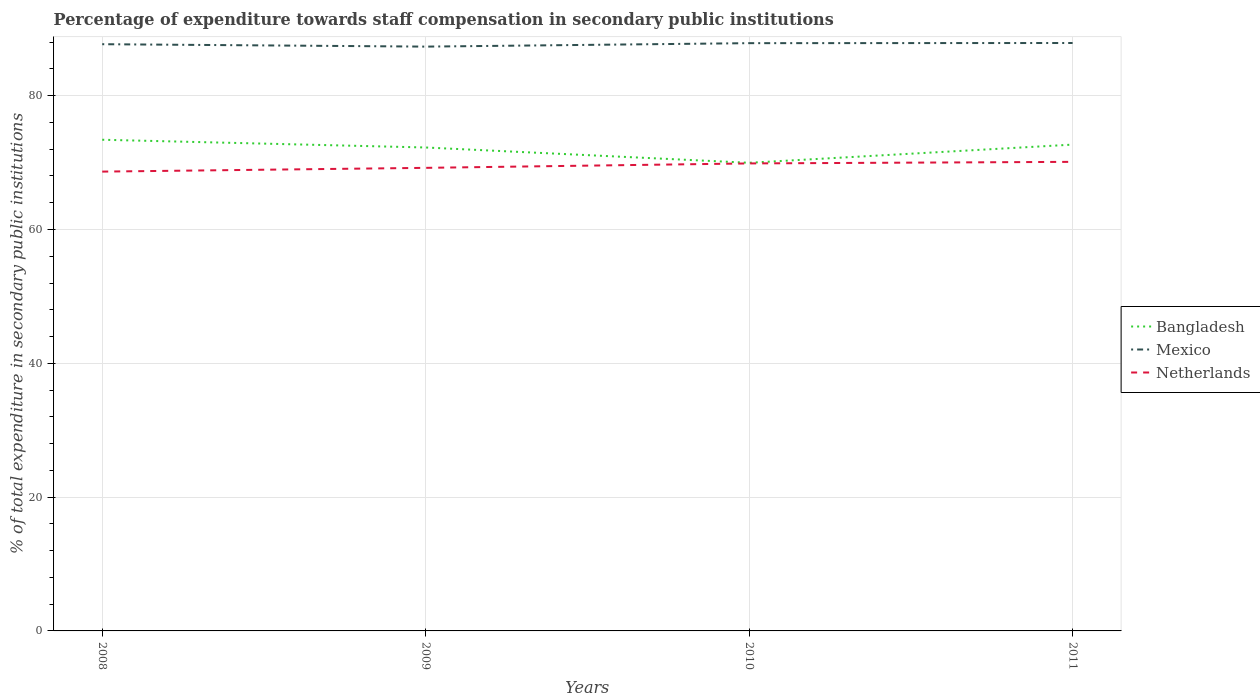How many different coloured lines are there?
Provide a succinct answer. 3. Is the number of lines equal to the number of legend labels?
Give a very brief answer. Yes. Across all years, what is the maximum percentage of expenditure towards staff compensation in Mexico?
Give a very brief answer. 87.34. In which year was the percentage of expenditure towards staff compensation in Bangladesh maximum?
Provide a succinct answer. 2010. What is the total percentage of expenditure towards staff compensation in Mexico in the graph?
Offer a very short reply. -0.54. What is the difference between the highest and the second highest percentage of expenditure towards staff compensation in Netherlands?
Provide a short and direct response. 1.46. How many years are there in the graph?
Your answer should be very brief. 4. What is the difference between two consecutive major ticks on the Y-axis?
Provide a succinct answer. 20. Are the values on the major ticks of Y-axis written in scientific E-notation?
Keep it short and to the point. No. Does the graph contain any zero values?
Keep it short and to the point. No. What is the title of the graph?
Make the answer very short. Percentage of expenditure towards staff compensation in secondary public institutions. Does "Panama" appear as one of the legend labels in the graph?
Keep it short and to the point. No. What is the label or title of the Y-axis?
Give a very brief answer. % of total expenditure in secondary public institutions. What is the % of total expenditure in secondary public institutions of Bangladesh in 2008?
Keep it short and to the point. 73.42. What is the % of total expenditure in secondary public institutions of Mexico in 2008?
Your answer should be very brief. 87.7. What is the % of total expenditure in secondary public institutions of Netherlands in 2008?
Offer a very short reply. 68.66. What is the % of total expenditure in secondary public institutions of Bangladesh in 2009?
Offer a very short reply. 72.26. What is the % of total expenditure in secondary public institutions of Mexico in 2009?
Keep it short and to the point. 87.34. What is the % of total expenditure in secondary public institutions of Netherlands in 2009?
Your response must be concise. 69.22. What is the % of total expenditure in secondary public institutions in Bangladesh in 2010?
Keep it short and to the point. 69.97. What is the % of total expenditure in secondary public institutions of Mexico in 2010?
Provide a short and direct response. 87.85. What is the % of total expenditure in secondary public institutions of Netherlands in 2010?
Keep it short and to the point. 69.88. What is the % of total expenditure in secondary public institutions of Bangladesh in 2011?
Offer a terse response. 72.69. What is the % of total expenditure in secondary public institutions in Mexico in 2011?
Your response must be concise. 87.88. What is the % of total expenditure in secondary public institutions in Netherlands in 2011?
Your answer should be very brief. 70.11. Across all years, what is the maximum % of total expenditure in secondary public institutions of Bangladesh?
Offer a very short reply. 73.42. Across all years, what is the maximum % of total expenditure in secondary public institutions of Mexico?
Your answer should be compact. 87.88. Across all years, what is the maximum % of total expenditure in secondary public institutions in Netherlands?
Make the answer very short. 70.11. Across all years, what is the minimum % of total expenditure in secondary public institutions in Bangladesh?
Offer a very short reply. 69.97. Across all years, what is the minimum % of total expenditure in secondary public institutions of Mexico?
Make the answer very short. 87.34. Across all years, what is the minimum % of total expenditure in secondary public institutions in Netherlands?
Keep it short and to the point. 68.66. What is the total % of total expenditure in secondary public institutions in Bangladesh in the graph?
Your answer should be very brief. 288.34. What is the total % of total expenditure in secondary public institutions in Mexico in the graph?
Provide a succinct answer. 350.77. What is the total % of total expenditure in secondary public institutions of Netherlands in the graph?
Give a very brief answer. 277.86. What is the difference between the % of total expenditure in secondary public institutions in Bangladesh in 2008 and that in 2009?
Provide a short and direct response. 1.16. What is the difference between the % of total expenditure in secondary public institutions in Mexico in 2008 and that in 2009?
Ensure brevity in your answer.  0.36. What is the difference between the % of total expenditure in secondary public institutions of Netherlands in 2008 and that in 2009?
Provide a succinct answer. -0.56. What is the difference between the % of total expenditure in secondary public institutions of Bangladesh in 2008 and that in 2010?
Make the answer very short. 3.44. What is the difference between the % of total expenditure in secondary public institutions of Mexico in 2008 and that in 2010?
Make the answer very short. -0.15. What is the difference between the % of total expenditure in secondary public institutions of Netherlands in 2008 and that in 2010?
Your answer should be very brief. -1.22. What is the difference between the % of total expenditure in secondary public institutions in Bangladesh in 2008 and that in 2011?
Make the answer very short. 0.73. What is the difference between the % of total expenditure in secondary public institutions in Mexico in 2008 and that in 2011?
Your response must be concise. -0.18. What is the difference between the % of total expenditure in secondary public institutions in Netherlands in 2008 and that in 2011?
Your answer should be very brief. -1.46. What is the difference between the % of total expenditure in secondary public institutions of Bangladesh in 2009 and that in 2010?
Your answer should be compact. 2.29. What is the difference between the % of total expenditure in secondary public institutions in Mexico in 2009 and that in 2010?
Provide a short and direct response. -0.52. What is the difference between the % of total expenditure in secondary public institutions in Netherlands in 2009 and that in 2010?
Provide a succinct answer. -0.66. What is the difference between the % of total expenditure in secondary public institutions in Bangladesh in 2009 and that in 2011?
Your response must be concise. -0.43. What is the difference between the % of total expenditure in secondary public institutions of Mexico in 2009 and that in 2011?
Your answer should be compact. -0.54. What is the difference between the % of total expenditure in secondary public institutions in Netherlands in 2009 and that in 2011?
Give a very brief answer. -0.9. What is the difference between the % of total expenditure in secondary public institutions of Bangladesh in 2010 and that in 2011?
Keep it short and to the point. -2.72. What is the difference between the % of total expenditure in secondary public institutions of Mexico in 2010 and that in 2011?
Provide a succinct answer. -0.02. What is the difference between the % of total expenditure in secondary public institutions in Netherlands in 2010 and that in 2011?
Provide a succinct answer. -0.24. What is the difference between the % of total expenditure in secondary public institutions of Bangladesh in 2008 and the % of total expenditure in secondary public institutions of Mexico in 2009?
Provide a short and direct response. -13.92. What is the difference between the % of total expenditure in secondary public institutions of Bangladesh in 2008 and the % of total expenditure in secondary public institutions of Netherlands in 2009?
Your answer should be very brief. 4.2. What is the difference between the % of total expenditure in secondary public institutions of Mexico in 2008 and the % of total expenditure in secondary public institutions of Netherlands in 2009?
Provide a succinct answer. 18.48. What is the difference between the % of total expenditure in secondary public institutions in Bangladesh in 2008 and the % of total expenditure in secondary public institutions in Mexico in 2010?
Your response must be concise. -14.44. What is the difference between the % of total expenditure in secondary public institutions of Bangladesh in 2008 and the % of total expenditure in secondary public institutions of Netherlands in 2010?
Your answer should be very brief. 3.54. What is the difference between the % of total expenditure in secondary public institutions of Mexico in 2008 and the % of total expenditure in secondary public institutions of Netherlands in 2010?
Make the answer very short. 17.82. What is the difference between the % of total expenditure in secondary public institutions in Bangladesh in 2008 and the % of total expenditure in secondary public institutions in Mexico in 2011?
Provide a succinct answer. -14.46. What is the difference between the % of total expenditure in secondary public institutions of Bangladesh in 2008 and the % of total expenditure in secondary public institutions of Netherlands in 2011?
Offer a terse response. 3.3. What is the difference between the % of total expenditure in secondary public institutions of Mexico in 2008 and the % of total expenditure in secondary public institutions of Netherlands in 2011?
Provide a short and direct response. 17.59. What is the difference between the % of total expenditure in secondary public institutions of Bangladesh in 2009 and the % of total expenditure in secondary public institutions of Mexico in 2010?
Keep it short and to the point. -15.59. What is the difference between the % of total expenditure in secondary public institutions in Bangladesh in 2009 and the % of total expenditure in secondary public institutions in Netherlands in 2010?
Offer a terse response. 2.38. What is the difference between the % of total expenditure in secondary public institutions in Mexico in 2009 and the % of total expenditure in secondary public institutions in Netherlands in 2010?
Keep it short and to the point. 17.46. What is the difference between the % of total expenditure in secondary public institutions in Bangladesh in 2009 and the % of total expenditure in secondary public institutions in Mexico in 2011?
Offer a very short reply. -15.62. What is the difference between the % of total expenditure in secondary public institutions in Bangladesh in 2009 and the % of total expenditure in secondary public institutions in Netherlands in 2011?
Your answer should be very brief. 2.15. What is the difference between the % of total expenditure in secondary public institutions in Mexico in 2009 and the % of total expenditure in secondary public institutions in Netherlands in 2011?
Keep it short and to the point. 17.22. What is the difference between the % of total expenditure in secondary public institutions in Bangladesh in 2010 and the % of total expenditure in secondary public institutions in Mexico in 2011?
Your answer should be very brief. -17.9. What is the difference between the % of total expenditure in secondary public institutions in Bangladesh in 2010 and the % of total expenditure in secondary public institutions in Netherlands in 2011?
Keep it short and to the point. -0.14. What is the difference between the % of total expenditure in secondary public institutions in Mexico in 2010 and the % of total expenditure in secondary public institutions in Netherlands in 2011?
Keep it short and to the point. 17.74. What is the average % of total expenditure in secondary public institutions in Bangladesh per year?
Your answer should be very brief. 72.09. What is the average % of total expenditure in secondary public institutions in Mexico per year?
Give a very brief answer. 87.69. What is the average % of total expenditure in secondary public institutions in Netherlands per year?
Your answer should be compact. 69.47. In the year 2008, what is the difference between the % of total expenditure in secondary public institutions in Bangladesh and % of total expenditure in secondary public institutions in Mexico?
Provide a short and direct response. -14.28. In the year 2008, what is the difference between the % of total expenditure in secondary public institutions of Bangladesh and % of total expenditure in secondary public institutions of Netherlands?
Provide a succinct answer. 4.76. In the year 2008, what is the difference between the % of total expenditure in secondary public institutions in Mexico and % of total expenditure in secondary public institutions in Netherlands?
Give a very brief answer. 19.04. In the year 2009, what is the difference between the % of total expenditure in secondary public institutions of Bangladesh and % of total expenditure in secondary public institutions of Mexico?
Offer a very short reply. -15.08. In the year 2009, what is the difference between the % of total expenditure in secondary public institutions of Bangladesh and % of total expenditure in secondary public institutions of Netherlands?
Offer a terse response. 3.04. In the year 2009, what is the difference between the % of total expenditure in secondary public institutions of Mexico and % of total expenditure in secondary public institutions of Netherlands?
Your answer should be compact. 18.12. In the year 2010, what is the difference between the % of total expenditure in secondary public institutions of Bangladesh and % of total expenditure in secondary public institutions of Mexico?
Provide a succinct answer. -17.88. In the year 2010, what is the difference between the % of total expenditure in secondary public institutions of Bangladesh and % of total expenditure in secondary public institutions of Netherlands?
Offer a terse response. 0.1. In the year 2010, what is the difference between the % of total expenditure in secondary public institutions in Mexico and % of total expenditure in secondary public institutions in Netherlands?
Ensure brevity in your answer.  17.98. In the year 2011, what is the difference between the % of total expenditure in secondary public institutions of Bangladesh and % of total expenditure in secondary public institutions of Mexico?
Provide a short and direct response. -15.19. In the year 2011, what is the difference between the % of total expenditure in secondary public institutions of Bangladesh and % of total expenditure in secondary public institutions of Netherlands?
Give a very brief answer. 2.58. In the year 2011, what is the difference between the % of total expenditure in secondary public institutions in Mexico and % of total expenditure in secondary public institutions in Netherlands?
Your answer should be very brief. 17.76. What is the ratio of the % of total expenditure in secondary public institutions in Netherlands in 2008 to that in 2009?
Ensure brevity in your answer.  0.99. What is the ratio of the % of total expenditure in secondary public institutions in Bangladesh in 2008 to that in 2010?
Offer a very short reply. 1.05. What is the ratio of the % of total expenditure in secondary public institutions in Mexico in 2008 to that in 2010?
Make the answer very short. 1. What is the ratio of the % of total expenditure in secondary public institutions in Netherlands in 2008 to that in 2010?
Offer a terse response. 0.98. What is the ratio of the % of total expenditure in secondary public institutions of Mexico in 2008 to that in 2011?
Give a very brief answer. 1. What is the ratio of the % of total expenditure in secondary public institutions of Netherlands in 2008 to that in 2011?
Offer a very short reply. 0.98. What is the ratio of the % of total expenditure in secondary public institutions of Bangladesh in 2009 to that in 2010?
Ensure brevity in your answer.  1.03. What is the ratio of the % of total expenditure in secondary public institutions in Mexico in 2009 to that in 2010?
Provide a short and direct response. 0.99. What is the ratio of the % of total expenditure in secondary public institutions in Netherlands in 2009 to that in 2010?
Give a very brief answer. 0.99. What is the ratio of the % of total expenditure in secondary public institutions of Netherlands in 2009 to that in 2011?
Keep it short and to the point. 0.99. What is the ratio of the % of total expenditure in secondary public institutions of Bangladesh in 2010 to that in 2011?
Your answer should be compact. 0.96. What is the difference between the highest and the second highest % of total expenditure in secondary public institutions of Bangladesh?
Offer a very short reply. 0.73. What is the difference between the highest and the second highest % of total expenditure in secondary public institutions in Mexico?
Offer a terse response. 0.02. What is the difference between the highest and the second highest % of total expenditure in secondary public institutions in Netherlands?
Your response must be concise. 0.24. What is the difference between the highest and the lowest % of total expenditure in secondary public institutions in Bangladesh?
Your answer should be compact. 3.44. What is the difference between the highest and the lowest % of total expenditure in secondary public institutions in Mexico?
Provide a succinct answer. 0.54. What is the difference between the highest and the lowest % of total expenditure in secondary public institutions in Netherlands?
Keep it short and to the point. 1.46. 